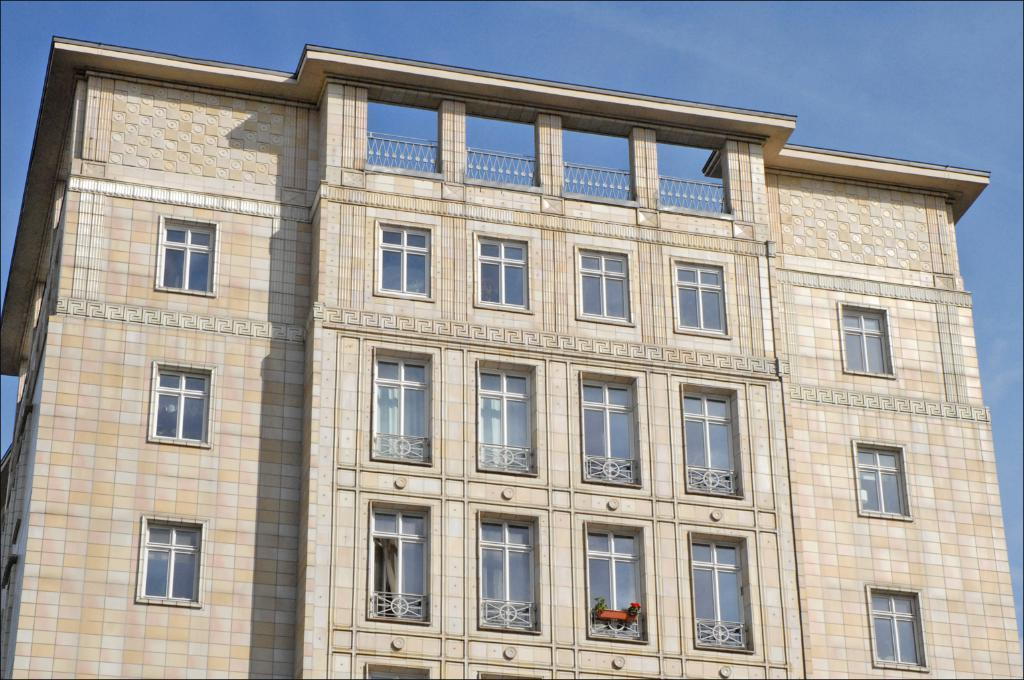What is the main subject of the image? The main subject of the image is a building. Can you describe the building in the image? The building has many windows. What type of insect is crawling on the windows of the building in the image? There is no insect present on the windows of the building in the image. What type of competition is being held in the building in the image? There is no information about a competition being held in the building in the image. 